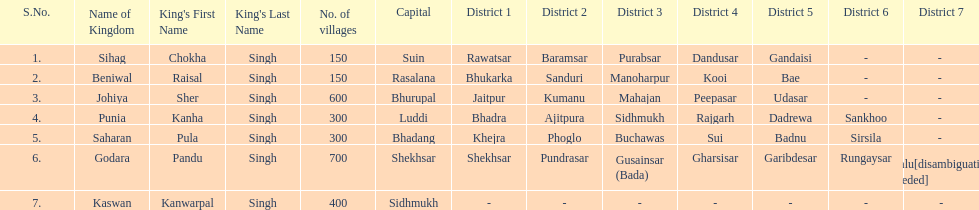What is the number of kingdoms that have more than 300 villages? 3. 